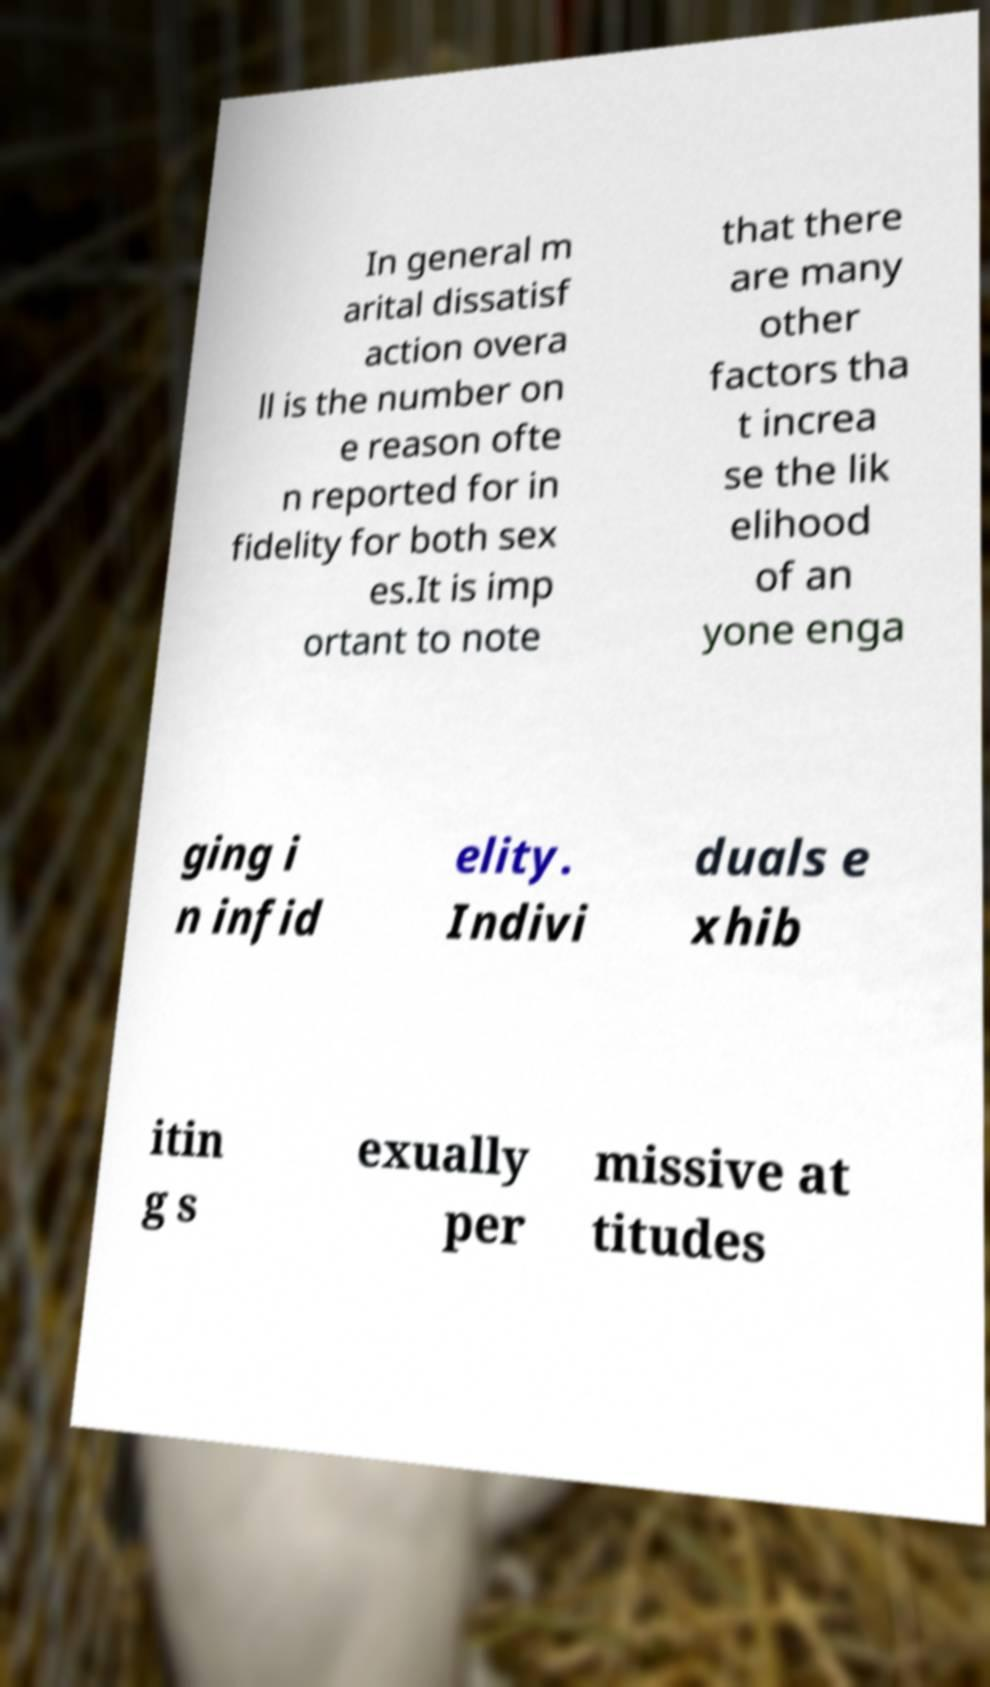I need the written content from this picture converted into text. Can you do that? In general m arital dissatisf action overa ll is the number on e reason ofte n reported for in fidelity for both sex es.It is imp ortant to note that there are many other factors tha t increa se the lik elihood of an yone enga ging i n infid elity. Indivi duals e xhib itin g s exually per missive at titudes 